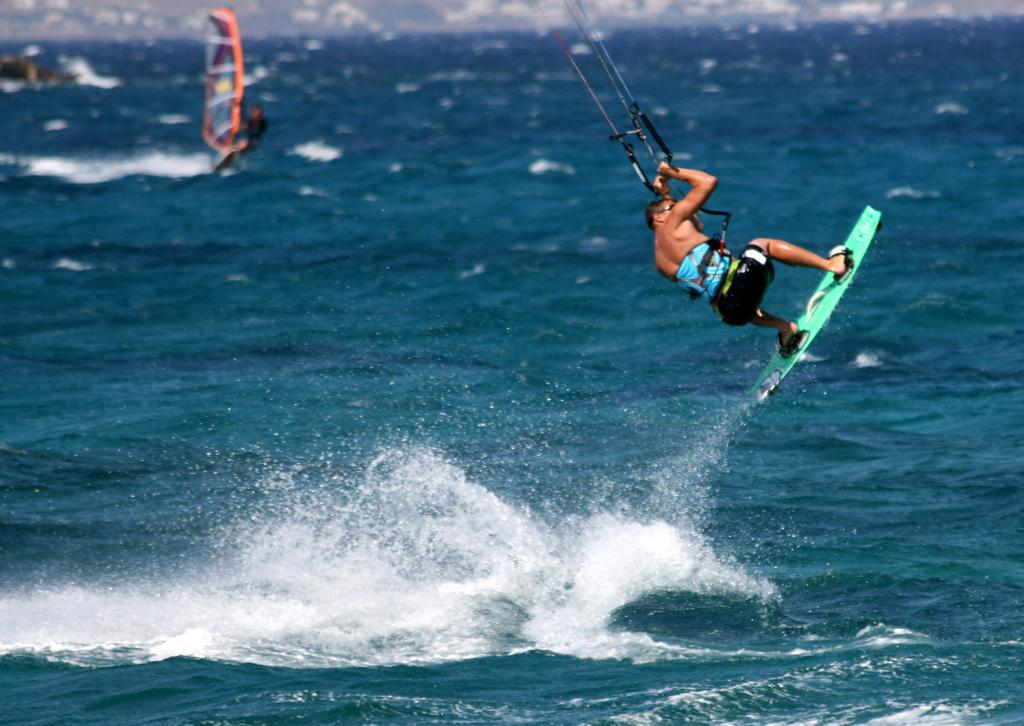What activity is the person in the image participating in? The person is kite surfing in the image. Is the person kite surfing stationary or in motion? The person kite surfing is in motion. What other water sport can be seen in the image? There is a person windsurfing in the image. Where is the person windsurfing located? The person windsurfing is on the water. How many parcels is the person kite surfing holding in the image? There are no parcels visible in the image; the person is kite surfing. What type of bun is the person windsurfing wearing in the image? There is no person wearing a bun in the image; the focus is on the water sports activities. 